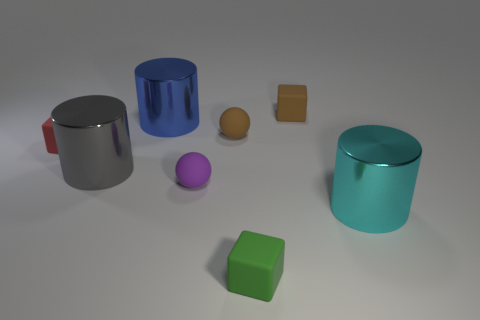Add 1 green rubber blocks. How many objects exist? 9 Subtract all purple balls. How many balls are left? 1 Subtract all blue cylinders. How many cylinders are left? 2 Subtract 0 yellow spheres. How many objects are left? 8 Subtract all cubes. How many objects are left? 5 Subtract 1 cubes. How many cubes are left? 2 Subtract all blue spheres. Subtract all brown cubes. How many spheres are left? 2 Subtract all gray blocks. How many red cylinders are left? 0 Subtract all large cyan metallic objects. Subtract all big blue cylinders. How many objects are left? 6 Add 2 cyan metal cylinders. How many cyan metal cylinders are left? 3 